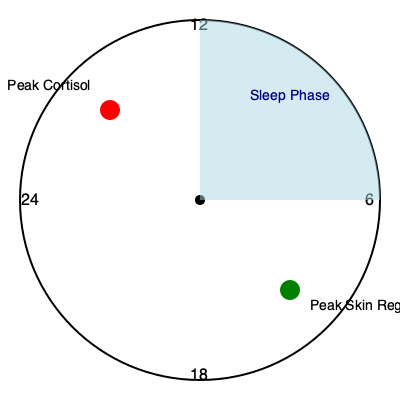Based on the 24-hour circadian rhythm clock shown, at approximately what time does peak skin regeneration occur, and how does this relate to sleep quality for optimal skin health? 1. Observe the 24-hour circadian rhythm clock in the image.
2. Locate the green circle labeled "Peak Skin Regeneration."
3. The green circle is positioned between 18:00 (6 PM) and 24:00 (12 AM), approximately at 22:00 (10 PM).
4. Note that the blue shaded area represents the sleep phase, typically starting around 22:00 (10 PM) and ending around 6:00 (6 AM).
5. Peak skin regeneration coincides with the beginning of the sleep phase.
6. During sleep, the body enters a state of repair and regeneration.
7. Growth hormone secretion increases during deep sleep stages, promoting cell reproduction and regeneration.
8. Melatonin, a sleep-regulating hormone, also acts as an antioxidant, protecting skin cells from damage.
9. Quality sleep ensures longer periods in deep sleep stages, maximizing skin regeneration potential.
10. Cortisol, a stress hormone that can break down collagen, is at its lowest during this time (peaks in the morning, as shown by the red circle).
11. For optimal skin health, it's crucial to maintain a consistent sleep schedule aligned with this natural circadian rhythm, allowing for maximum skin regeneration during peak hours.
Answer: Peak skin regeneration occurs around 22:00 (10 PM), coinciding with the start of the sleep phase, emphasizing the importance of quality sleep for optimal skin health and regeneration. 